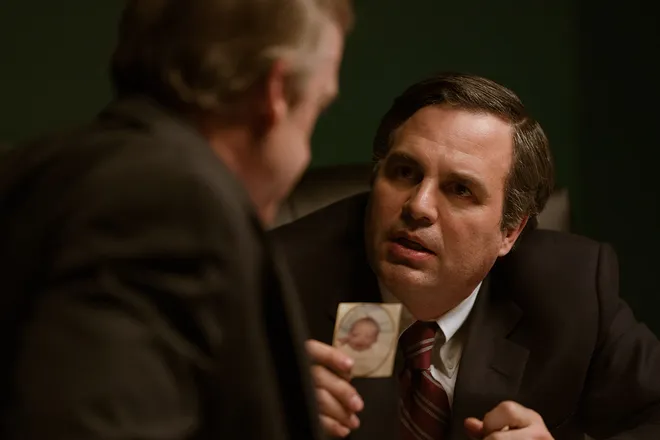How does the lighting in this scene affect its mood? The lighting in this scene utilizes a dim, greenish hue that creates a somber and intense atmosphere, emphasizing the gravity of the conversation between the two individuals. It serves to focus the viewer's attention on the expressions and interaction of the characters, further suggesting that there may be an important or dramatic context to their discussion. 